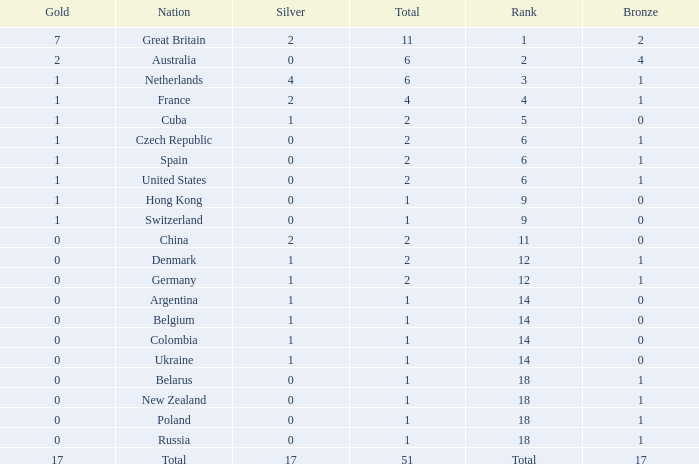Tell me the lowest gold for rank of 6 and total less than 2 None. 